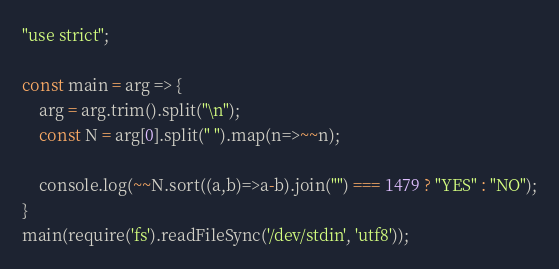Convert code to text. <code><loc_0><loc_0><loc_500><loc_500><_JavaScript_>"use strict";
    
const main = arg => {
    arg = arg.trim().split("\n");
    const N = arg[0].split(" ").map(n=>~~n);
    
    console.log(~~N.sort((a,b)=>a-b).join("") === 1479 ? "YES" : "NO");
}
main(require('fs').readFileSync('/dev/stdin', 'utf8'));
</code> 